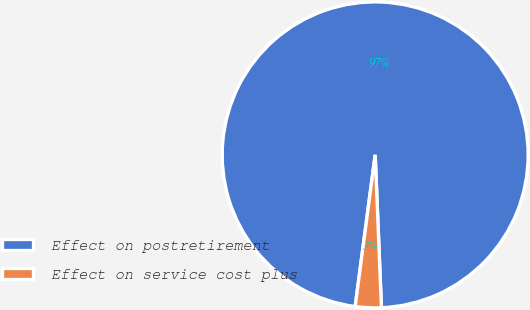Convert chart to OTSL. <chart><loc_0><loc_0><loc_500><loc_500><pie_chart><fcel>Effect on postretirement<fcel>Effect on service cost plus<nl><fcel>97.26%<fcel>2.74%<nl></chart> 